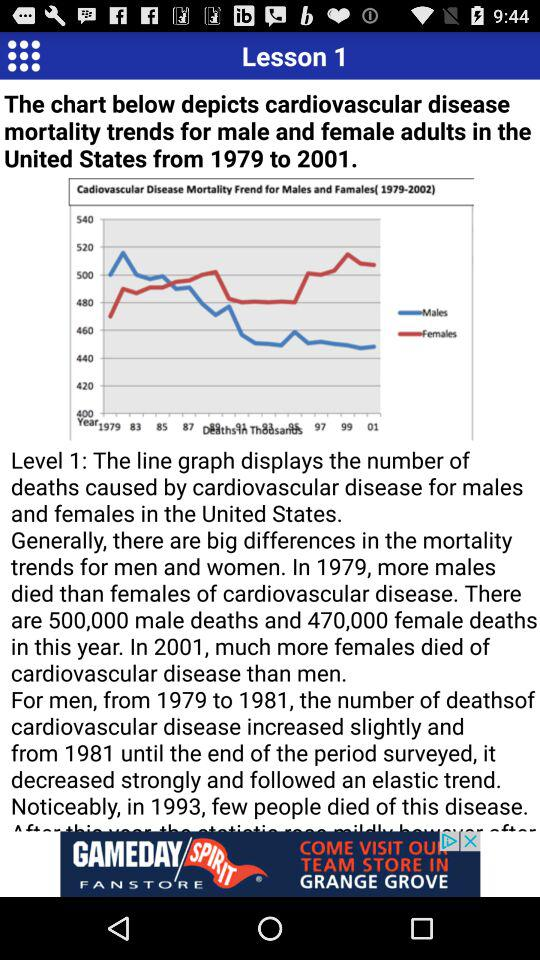What was the number of male deaths in the year 1979? The number of male deaths in the year 1979 was 500,000. 